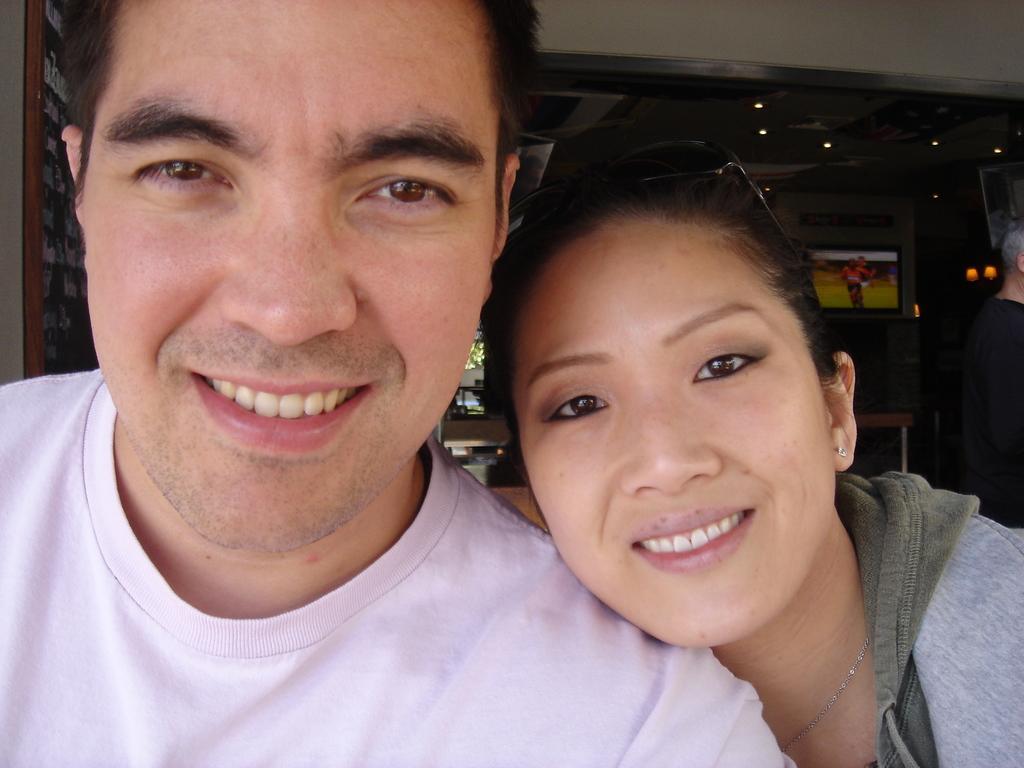Can you describe this image briefly? In this picture there is a man who is wearing pink t-shirt. Beside him there is a woman who is wearing hoodie. Both of them are smiling. In the back I can see the table, chairs, television and other objects. On the right there is a man who is wearing black t-shirt. He is standing near to the speaker. 